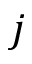<formula> <loc_0><loc_0><loc_500><loc_500>j</formula> 